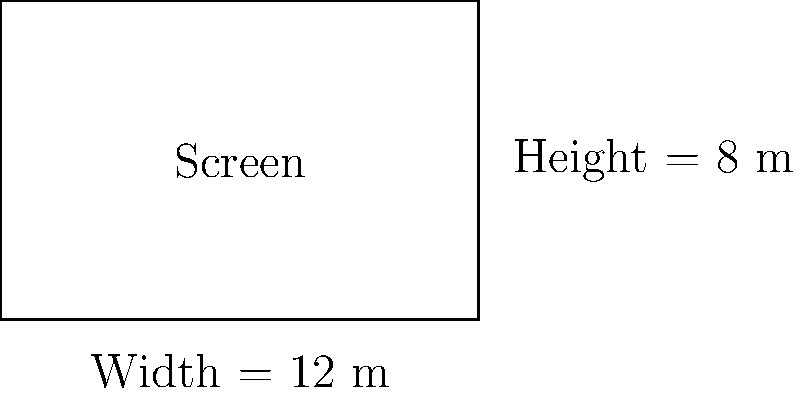As a global distributor aiming to expand Bollywood films' reach, you're assessing various international theaters. A prestigious cinema in London has a rectangular screen with a width of 12 meters and a height of 8 meters. Calculate the area of this screen in square meters. To calculate the area of a rectangular screen, we need to multiply its width by its height.

Given:
- Width of the screen = 12 meters
- Height of the screen = 8 meters

Step 1: Use the formula for the area of a rectangle
Area = Width × Height

Step 2: Substitute the values
Area = 12 m × 8 m

Step 3: Perform the multiplication
Area = 96 m²

Therefore, the area of the movie theater screen is 96 square meters.
Answer: 96 m² 